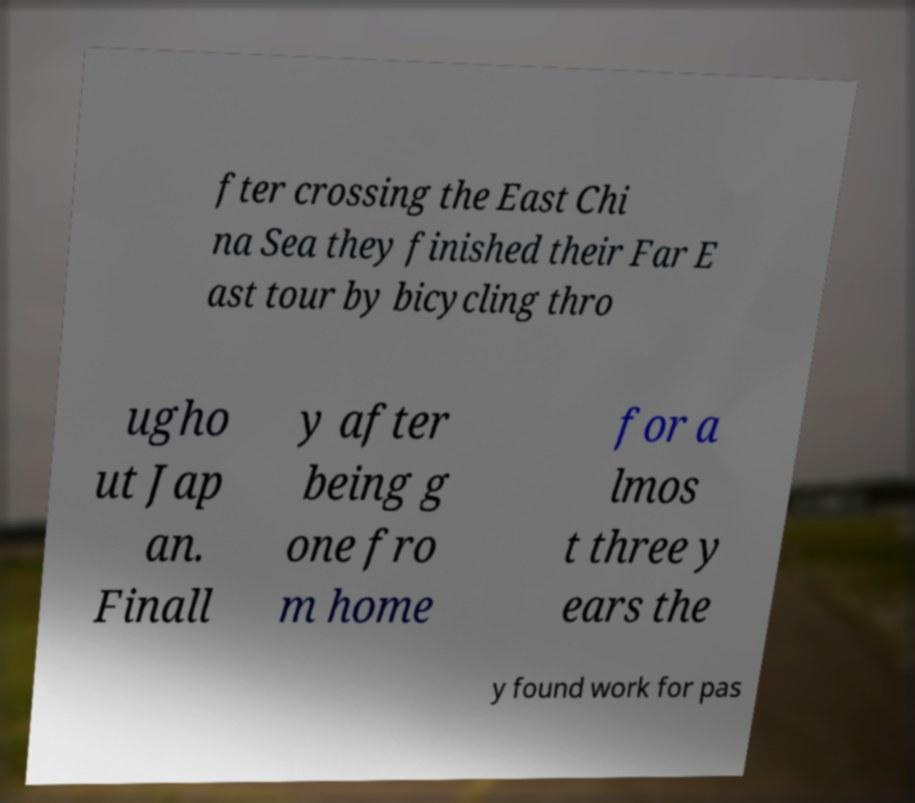For documentation purposes, I need the text within this image transcribed. Could you provide that? fter crossing the East Chi na Sea they finished their Far E ast tour by bicycling thro ugho ut Jap an. Finall y after being g one fro m home for a lmos t three y ears the y found work for pas 